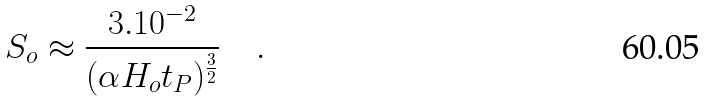<formula> <loc_0><loc_0><loc_500><loc_500>S _ { o } \approx \frac { 3 . 1 0 ^ { - 2 } } { ( { \alpha H _ { o } t _ { P } } ) ^ { \frac { 3 } { 2 } } } \quad .</formula> 